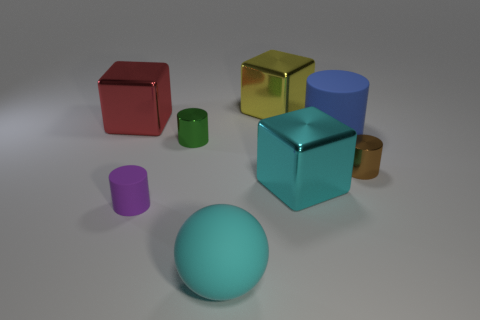Are there fewer matte cylinders in front of the large cyan block than large cyan shiny blocks that are left of the large red metallic object?
Ensure brevity in your answer.  No. How many other things are there of the same material as the tiny purple object?
Provide a short and direct response. 2. There is a purple cylinder that is the same size as the green metallic cylinder; what is it made of?
Your response must be concise. Rubber. How many blue things are either large blocks or spheres?
Provide a short and direct response. 0. What is the color of the large object that is in front of the red metallic thing and behind the small brown cylinder?
Offer a terse response. Blue. Is the cyan thing on the right side of the cyan matte object made of the same material as the block on the left side of the big cyan matte thing?
Give a very brief answer. Yes. Is the number of green cylinders that are in front of the big cyan block greater than the number of brown objects that are on the right side of the tiny brown object?
Your answer should be very brief. No. There is a matte object that is the same size as the green shiny object; what shape is it?
Your response must be concise. Cylinder. How many objects are small metallic cylinders or blue rubber cylinders right of the big cyan rubber ball?
Provide a short and direct response. 3. Is the color of the rubber sphere the same as the large cylinder?
Offer a terse response. No. 